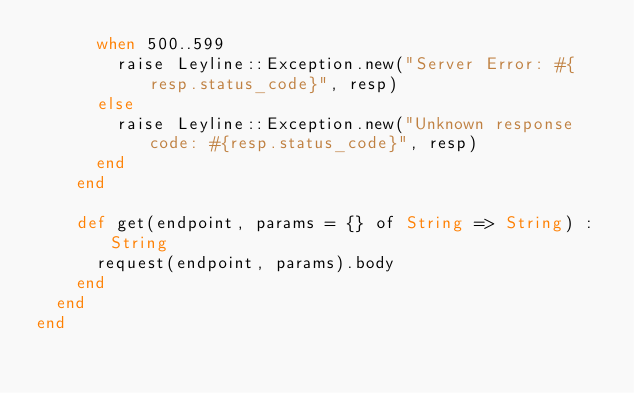Convert code to text. <code><loc_0><loc_0><loc_500><loc_500><_Crystal_>      when 500..599
        raise Leyline::Exception.new("Server Error: #{resp.status_code}", resp)
      else
        raise Leyline::Exception.new("Unknown response code: #{resp.status_code}", resp)
      end
    end

    def get(endpoint, params = {} of String => String) : String
      request(endpoint, params).body
    end
  end
end
</code> 